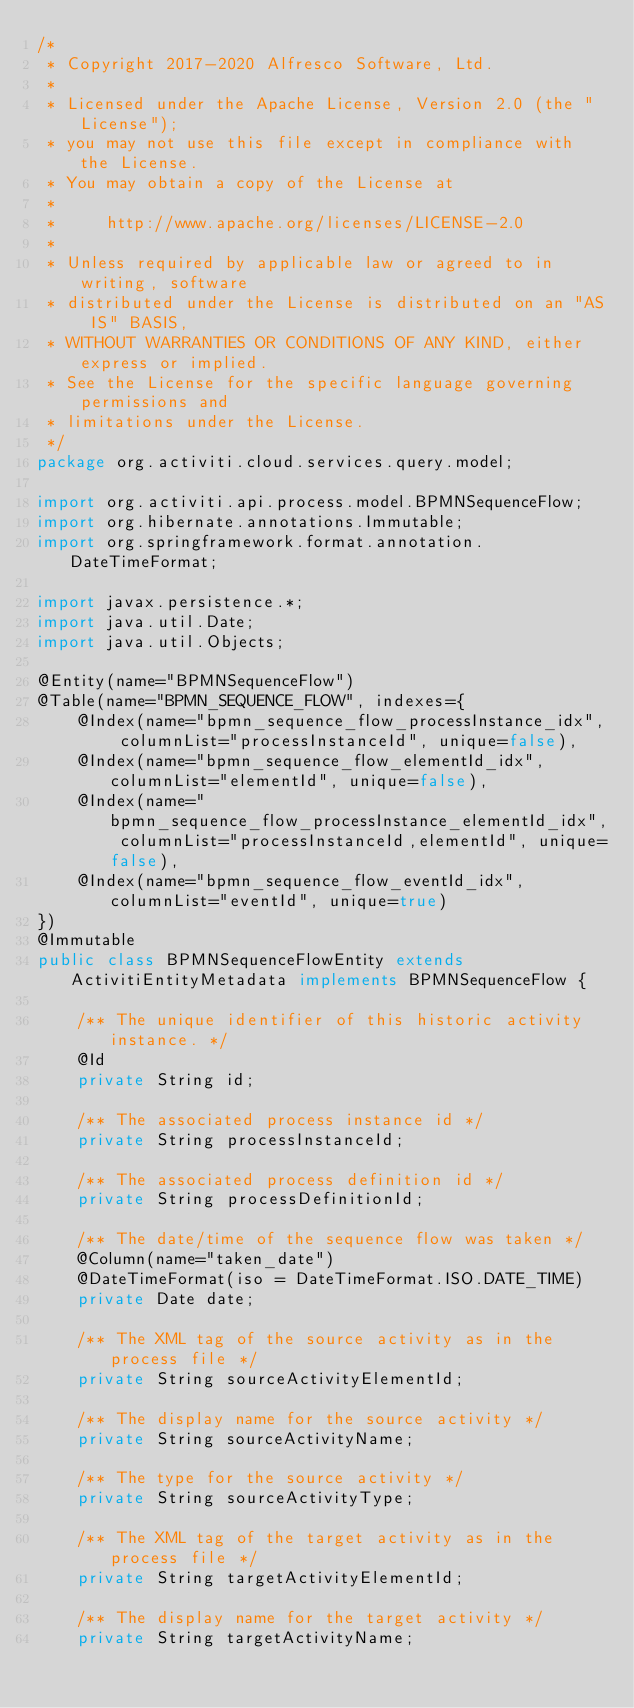Convert code to text. <code><loc_0><loc_0><loc_500><loc_500><_Java_>/*
 * Copyright 2017-2020 Alfresco Software, Ltd.
 *
 * Licensed under the Apache License, Version 2.0 (the "License");
 * you may not use this file except in compliance with the License.
 * You may obtain a copy of the License at
 *
 *     http://www.apache.org/licenses/LICENSE-2.0
 *
 * Unless required by applicable law or agreed to in writing, software
 * distributed under the License is distributed on an "AS IS" BASIS,
 * WITHOUT WARRANTIES OR CONDITIONS OF ANY KIND, either express or implied.
 * See the License for the specific language governing permissions and
 * limitations under the License.
 */
package org.activiti.cloud.services.query.model;

import org.activiti.api.process.model.BPMNSequenceFlow;
import org.hibernate.annotations.Immutable;
import org.springframework.format.annotation.DateTimeFormat;

import javax.persistence.*;
import java.util.Date;
import java.util.Objects;

@Entity(name="BPMNSequenceFlow")
@Table(name="BPMN_SEQUENCE_FLOW", indexes={
    @Index(name="bpmn_sequence_flow_processInstance_idx", columnList="processInstanceId", unique=false),
    @Index(name="bpmn_sequence_flow_elementId_idx", columnList="elementId", unique=false),
    @Index(name="bpmn_sequence_flow_processInstance_elementId_idx", columnList="processInstanceId,elementId", unique=false),
    @Index(name="bpmn_sequence_flow_eventId_idx", columnList="eventId", unique=true)
})
@Immutable
public class BPMNSequenceFlowEntity extends ActivitiEntityMetadata implements BPMNSequenceFlow {

    /** The unique identifier of this historic activity instance. */
    @Id
    private String id;

    /** The associated process instance id */
    private String processInstanceId;

    /** The associated process definition id */
    private String processDefinitionId;

    /** The date/time of the sequence flow was taken */
    @Column(name="taken_date")
    @DateTimeFormat(iso = DateTimeFormat.ISO.DATE_TIME)
    private Date date;

    /** The XML tag of the source activity as in the process file */
    private String sourceActivityElementId;

    /** The display name for the source activity */
    private String sourceActivityName;

    /** The type for the source activity */
    private String sourceActivityType;

    /** The XML tag of the target activity as in the process file */
    private String targetActivityElementId;

    /** The display name for the target activity */
    private String targetActivityName;
</code> 